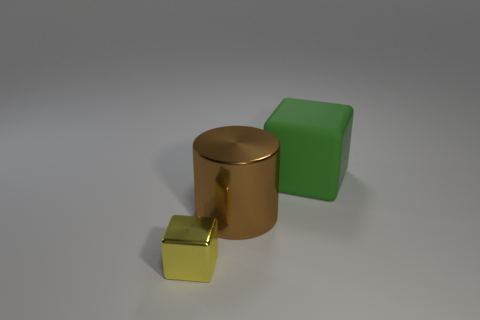The big thing in front of the green rubber cube has what shape? The large object positioned in front of the green cube is cylindrical. It has a circular base with a uniform diameter extending vertically, which is characteristic of a cylinder. 